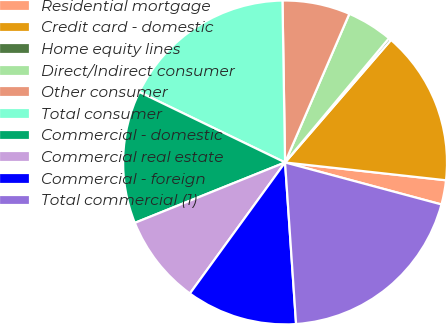<chart> <loc_0><loc_0><loc_500><loc_500><pie_chart><fcel>Residential mortgage<fcel>Credit card - domestic<fcel>Home equity lines<fcel>Direct/Indirect consumer<fcel>Other consumer<fcel>Total consumer<fcel>Commercial - domestic<fcel>Commercial real estate<fcel>Commercial - foreign<fcel>Total commercial (1)<nl><fcel>2.42%<fcel>15.41%<fcel>0.26%<fcel>4.59%<fcel>6.75%<fcel>17.58%<fcel>13.25%<fcel>8.92%<fcel>11.08%<fcel>19.74%<nl></chart> 